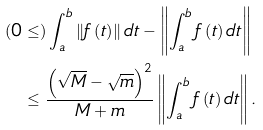Convert formula to latex. <formula><loc_0><loc_0><loc_500><loc_500>( 0 & \leq ) \int _ { a } ^ { b } \left \| f \left ( t \right ) \right \| d t - \left \| \int _ { a } ^ { b } f \left ( t \right ) d t \right \| \\ & \leq \frac { \left ( \sqrt { M } - \sqrt { m } \right ) ^ { 2 } } { M + m } \left \| \int _ { a } ^ { b } f \left ( t \right ) d t \right \| .</formula> 